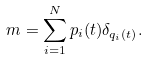Convert formula to latex. <formula><loc_0><loc_0><loc_500><loc_500>m = \sum _ { i = 1 } ^ { N } p _ { i } ( t ) \delta _ { q _ { i } ( t ) } .</formula> 